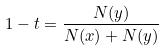<formula> <loc_0><loc_0><loc_500><loc_500>1 - t = \frac { N ( y ) } { N ( x ) + N ( y ) }</formula> 